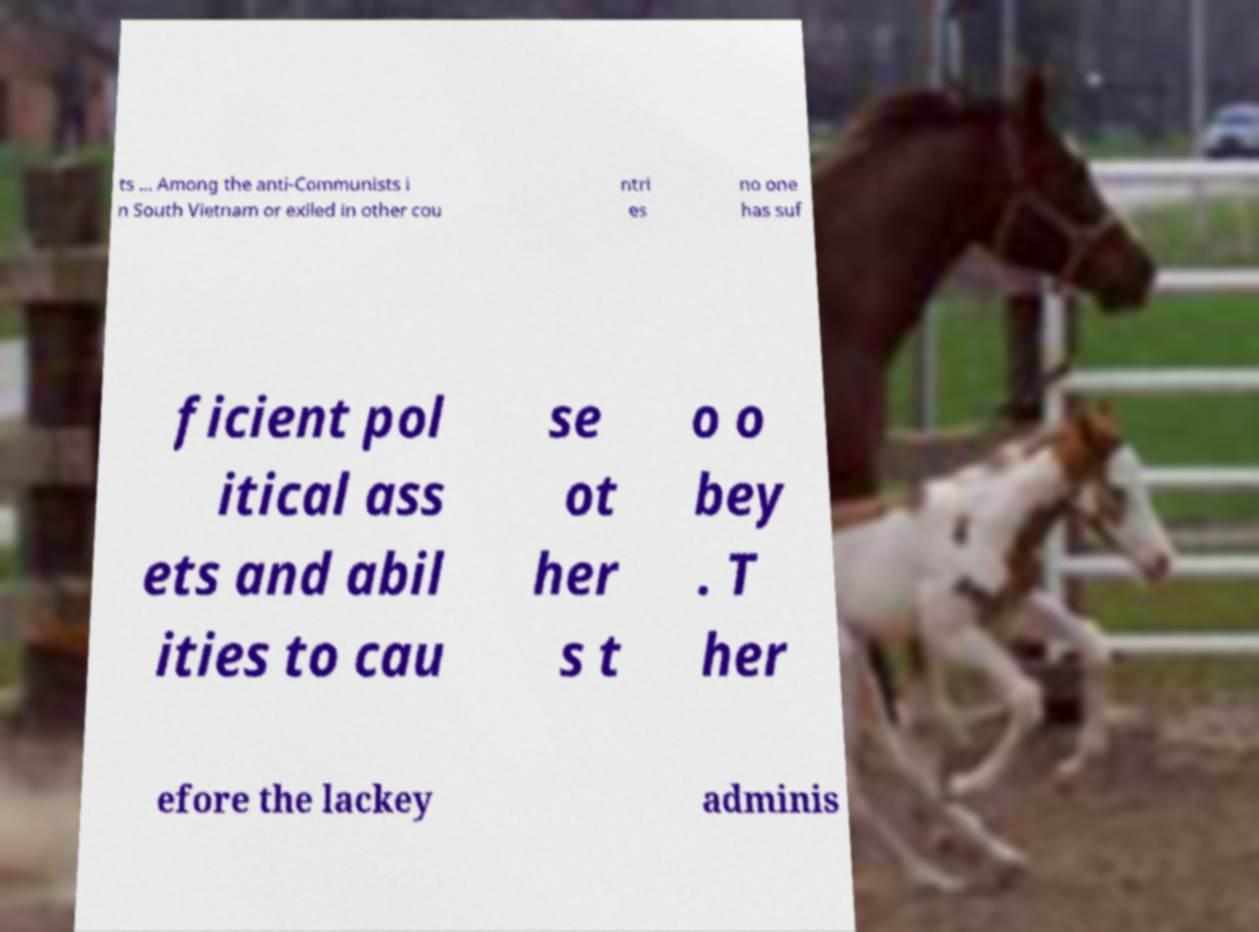I need the written content from this picture converted into text. Can you do that? ts ... Among the anti-Communists i n South Vietnam or exiled in other cou ntri es no one has suf ficient pol itical ass ets and abil ities to cau se ot her s t o o bey . T her efore the lackey adminis 